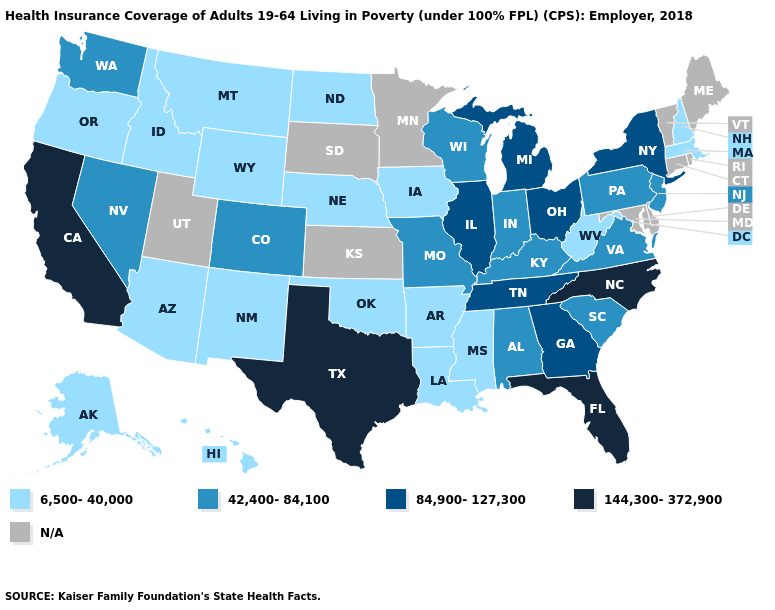Does the map have missing data?
Answer briefly. Yes. How many symbols are there in the legend?
Keep it brief. 5. What is the lowest value in states that border Arkansas?
Keep it brief. 6,500-40,000. Does Texas have the lowest value in the South?
Short answer required. No. What is the lowest value in the South?
Write a very short answer. 6,500-40,000. Name the states that have a value in the range 42,400-84,100?
Answer briefly. Alabama, Colorado, Indiana, Kentucky, Missouri, Nevada, New Jersey, Pennsylvania, South Carolina, Virginia, Washington, Wisconsin. What is the value of Hawaii?
Give a very brief answer. 6,500-40,000. What is the highest value in the USA?
Quick response, please. 144,300-372,900. What is the value of Ohio?
Keep it brief. 84,900-127,300. Among the states that border Missouri , which have the highest value?
Answer briefly. Illinois, Tennessee. What is the lowest value in the MidWest?
Quick response, please. 6,500-40,000. Name the states that have a value in the range N/A?
Concise answer only. Connecticut, Delaware, Kansas, Maine, Maryland, Minnesota, Rhode Island, South Dakota, Utah, Vermont. What is the value of Arkansas?
Keep it brief. 6,500-40,000. What is the value of Oklahoma?
Concise answer only. 6,500-40,000. 